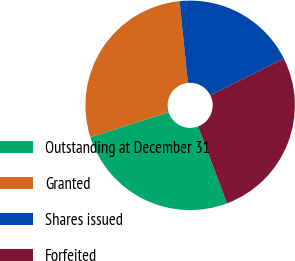Convert chart. <chart><loc_0><loc_0><loc_500><loc_500><pie_chart><fcel>Outstanding at December 31<fcel>Granted<fcel>Shares issued<fcel>Forfeited<nl><fcel>25.82%<fcel>28.3%<fcel>19.24%<fcel>26.65%<nl></chart> 